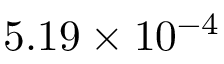<formula> <loc_0><loc_0><loc_500><loc_500>5 . 1 9 \times 1 0 ^ { - 4 }</formula> 